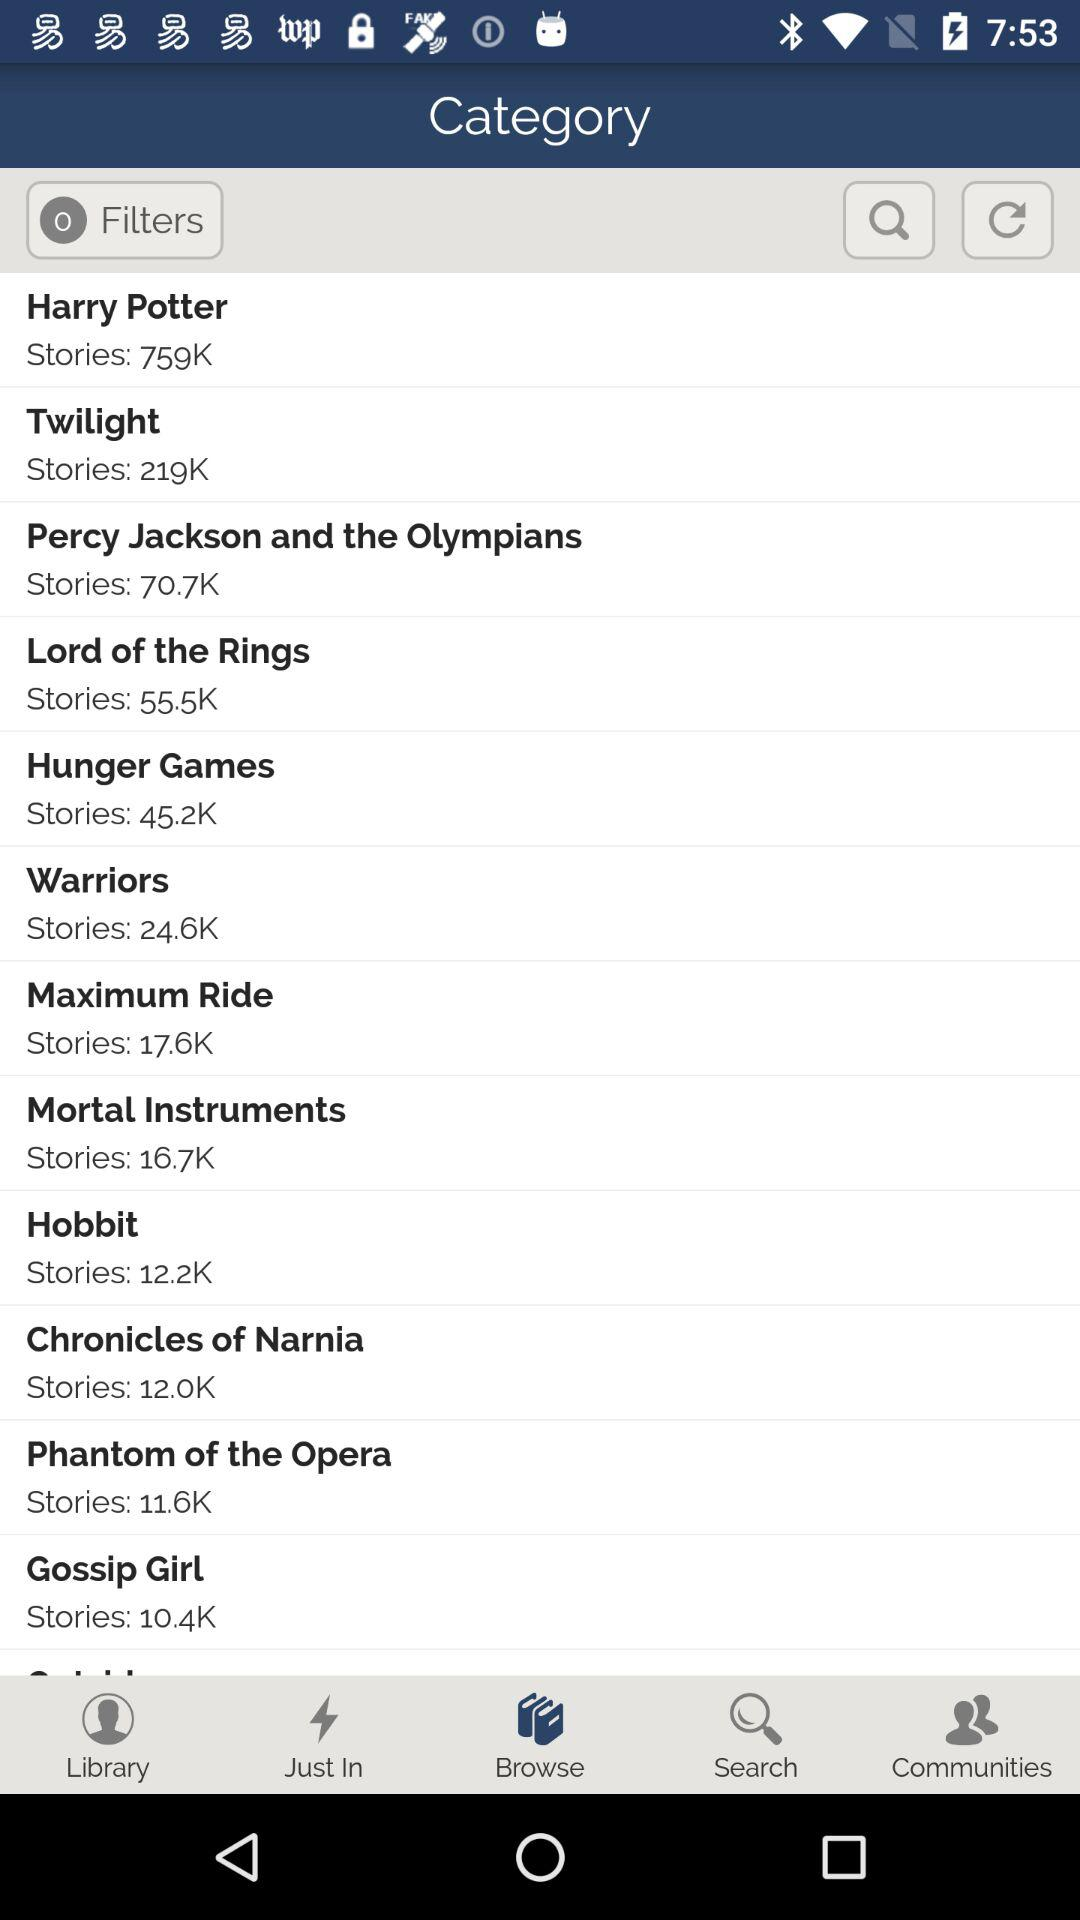How many stories are there in "Warriors"? There are 24.6K stories in "Warriors". 